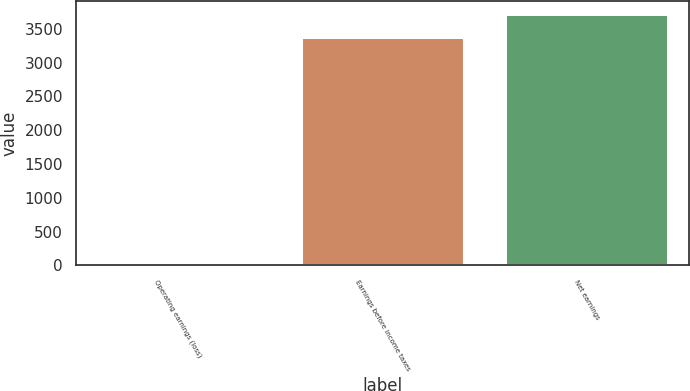Convert chart. <chart><loc_0><loc_0><loc_500><loc_500><bar_chart><fcel>Operating earnings (loss)<fcel>Earnings before income taxes<fcel>Net earnings<nl><fcel>7.3<fcel>3383.7<fcel>3721.34<nl></chart> 